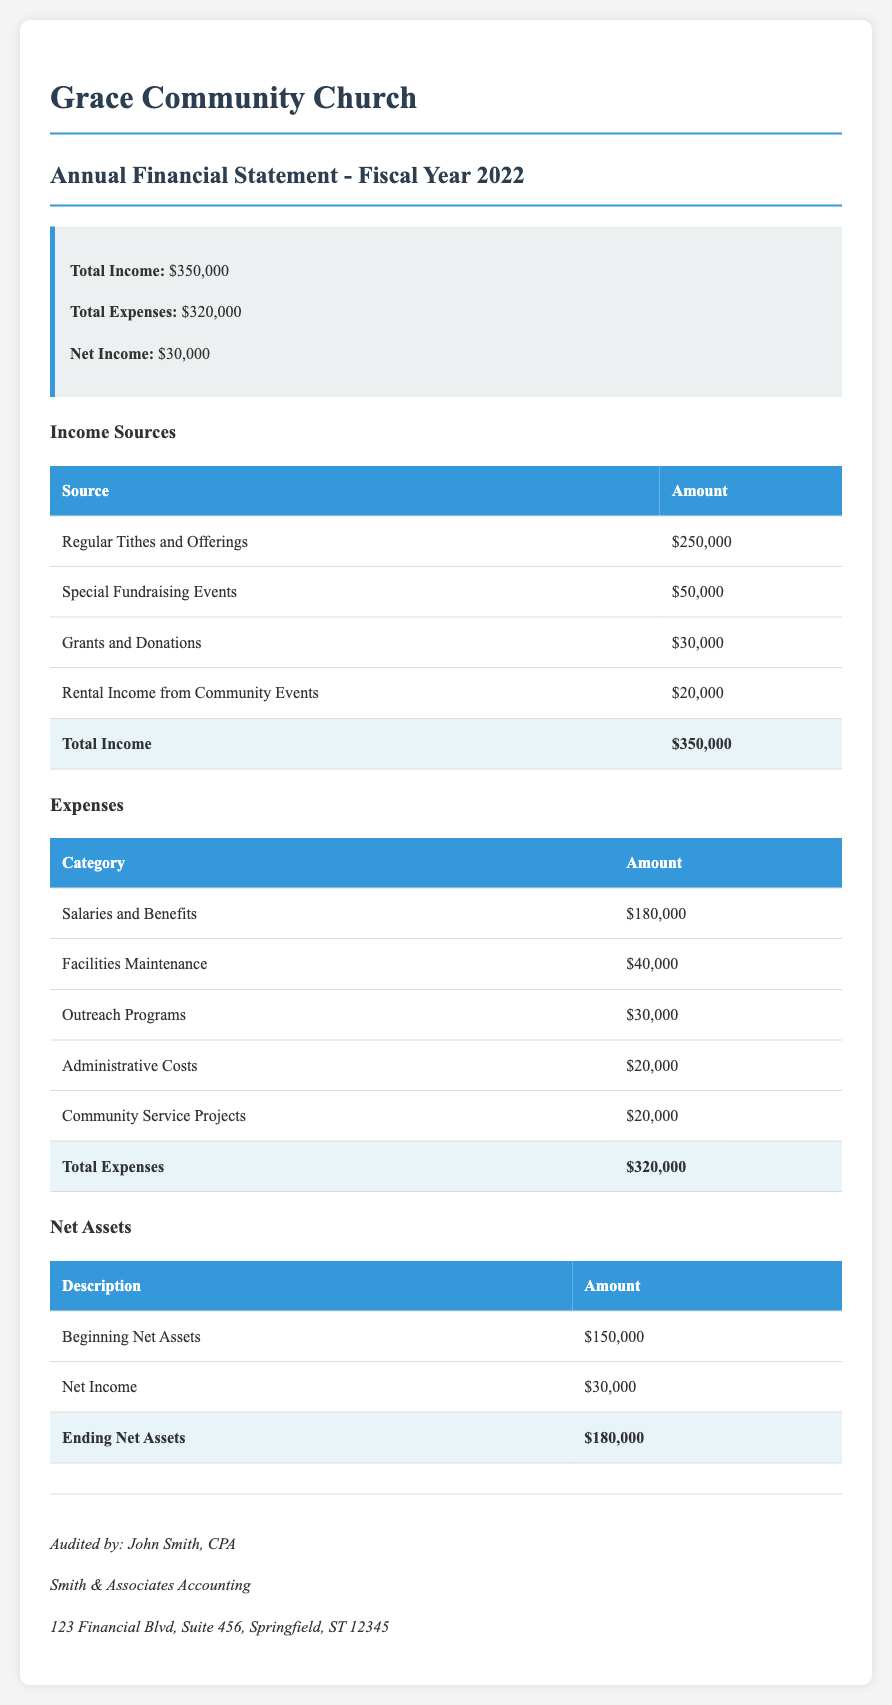What was the total income for the fiscal year 2022? The total income is stated in the summary box of the document, which sums up all income sources.
Answer: $350,000 What was the total expenses for the fiscal year 2022? The total expenses are provided in the summary box, reflecting the sum of all expense categories.
Answer: $320,000 What was the net income for the parish in 2022? The net income is calculated as total income minus total expenses, and it's given in the summary box of the document.
Answer: $30,000 What was the amount received from regular tithes and offerings? This figure is listed in the income sources table, specifically under regular tithes and offerings.
Answer: $250,000 What were the salaries and benefits expenses? This total is found under the expenses section of the document, detailing the salary and benefit costs.
Answer: $180,000 What is the amount for community service projects expenses? This is detailed in the expenses table, providing a specific line item for community service projects.
Answer: $20,000 What were the ending net assets for the fiscal year 2022? The ending net assets are provided at the bottom of the net assets table, reflecting the amount after net income is added to the beginning net assets.
Answer: $180,000 How much was allocated for outreach programs? This amount can be found in the expenses table under the outreach programs category.
Answer: $30,000 Who audited the financial statement? The auditor's name and firm are provided in the auditor information section at the bottom of the document.
Answer: John Smith, CPA 